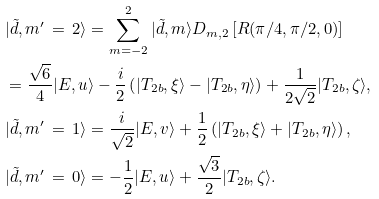<formula> <loc_0><loc_0><loc_500><loc_500>& | \tilde { d } , m ^ { \prime } \, = \, 2 \rangle = \sum _ { m = - 2 } ^ { 2 } | \tilde { d } , m \rangle D _ { m , 2 } \left [ R ( \pi / 4 , \pi / 2 , 0 ) \right ] \\ & = \frac { \sqrt { 6 } } { 4 } | E , u \rangle - \frac { i } { 2 } \left ( | T _ { 2 b } , \xi \rangle - | T _ { 2 b } , \eta \rangle \right ) + \frac { 1 } { 2 \sqrt { 2 } } | T _ { 2 b } , \zeta \rangle , \\ & | \tilde { d } , m ^ { \prime } \, = \, 1 \rangle = \frac { i } { \sqrt { 2 } } | E , v \rangle + \frac { 1 } { 2 } \left ( | T _ { 2 b } , \xi \rangle + | T _ { 2 b } , \eta \rangle \right ) , \\ & | \tilde { d } , m ^ { \prime } \, = \, 0 \rangle = - \frac { 1 } { 2 } | E , u \rangle + \frac { \sqrt { 3 } } { 2 } | T _ { 2 b } , \zeta \rangle .</formula> 